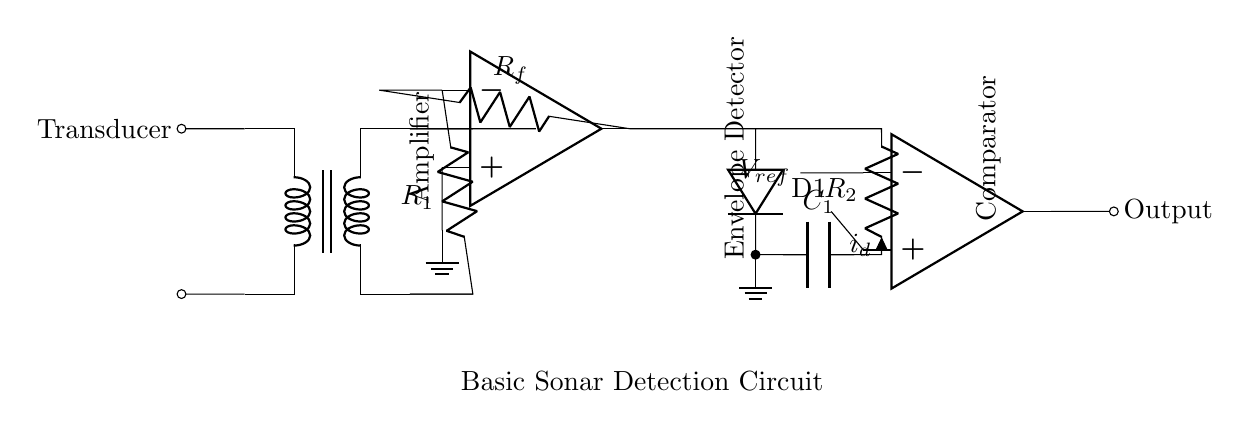What type of component is the transducer? The transducer is an electroacoustic component that converts electrical signals into sound waves and vice versa. It is visually represented at the leftmost part of the circuit diagram.
Answer: transducer What is connected to the output of the amplifier? The output of the amplifier connects to the envelope detector, which processes the amplified signal further. This is indicated by the line connecting the amplifier output to the envelope detector input in the diagram.
Answer: envelope detector What is the value of the resistor connected to the amplifier feedback? The resistor connected to the amplifier feedback is labeled as R_f, which indicates its role in determining the gain of the op-amp configuration. This can be identified from the labeling in the circuit diagram.
Answer: R_f How many op-amps are used in the circuit? The circuit contains two op-amps; one is used as an amplifier and the other as a comparator. This can be confirmed by visually counting the op-amp symbols in the diagram.
Answer: two What function does the envelope detector serve in this circuit? The envelope detector extracts the amplitude envelope of the signal waveform, converting it to a usable form. This function is essential for interpreting the sonar signals, as indicated by its position in the circuit flow.
Answer: extract amplitude envelope What does the comparator output depend on? The comparator's output depends on the reference voltage (V_ref) compared to the input signal from the envelope detector. The output occurs when the input signal exceeds V_ref, facilitating the detection process in sonar applications.
Answer: reference voltage What type of circuit is depicted here? This is a basic sonar detection circuit designed for underwater navigation, enabling distance measurement and object detection. This is identified from the labeling at the bottom of the diagram and the components used.
Answer: sonar detection circuit 